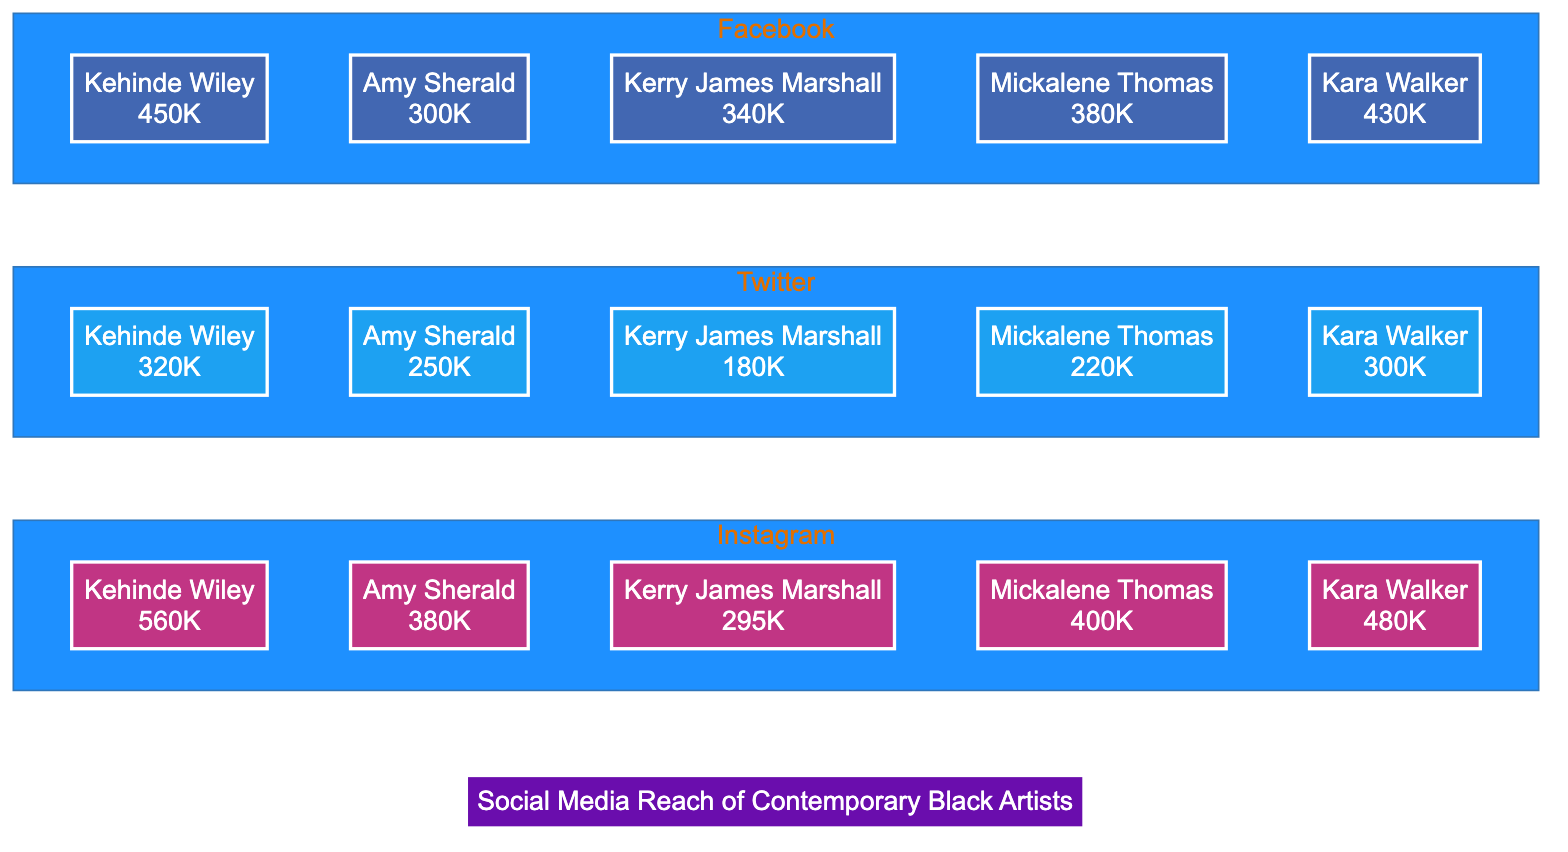What is Kehinde Wiley's reach on Instagram? The diagram shows that Kehinde Wiley has a reach of 560K on Instagram, indicated next to his name within the Instagram subgraph.
Answer: 560K Which artist has the highest Twitter reach? By examining the Twitter subgraph, Kehinde Wiley has the highest reach at 320K, which is listed next to his name.
Answer: Kehinde Wiley What is the reach of Amy Sherald on Facebook? In the Facebook subgraph, Amy Sherald has a reach of 300K, as shown next to her name in the diagram.
Answer: 300K Who has a higher reach on Instagram, Mickalene Thomas or Kara Walker? Comparing both artists within the Instagram subgraph, Mickalene Thomas has a reach of 400K, while Kara Walker has a reach of 480K, making Kara Walker the one with higher reach.
Answer: Kara Walker What is the total reach of Kerry James Marshall across all platforms? To calculate the total reach of Kerry James Marshall, add his reach values from all three platforms: 295K (Instagram) + 180K (Twitter) + 340K (Facebook), totaling 815K.
Answer: 815K Which social media platform shows Kehinde Wiley having the lowest reach? By comparing Kehinde Wiley's reach across the three platforms, he has the lowest reach on Twitter at 320K, as shown in the Twitter subgraph.
Answer: Twitter What is the difference in reach between Mickalene Thomas on Instagram and Facebook? Mickalene Thomas has a reach of 400K on Instagram and 380K on Facebook. The difference is calculated as 400K - 380K, resulting in 20K.
Answer: 20K Which artist has the largest combined reach from all three platforms? To find the artist with the largest combined reach, calculate the total reach for each: Kehinde Wiley (560K + 320K + 450K = 1330K), Amy Sherald (380K + 250K + 300K = 930K), Kerry James Marshall (295K + 180K + 340K = 815K), Mickalene Thomas (400K + 220K + 380K = 1000K), and Kara Walker (480K + 300K + 430K = 1210K). Kehinde Wiley has the highest total at 1330K.
Answer: Kehinde Wiley Which artist is represented in the middle of the bar chart in terms of reach on Instagram? By assessing the reach values in the Instagram subgraph and sorting them, Amy Sherald is the second lowest at 380K, placing her in the middle position when listed in order of reach.
Answer: Amy Sherald 